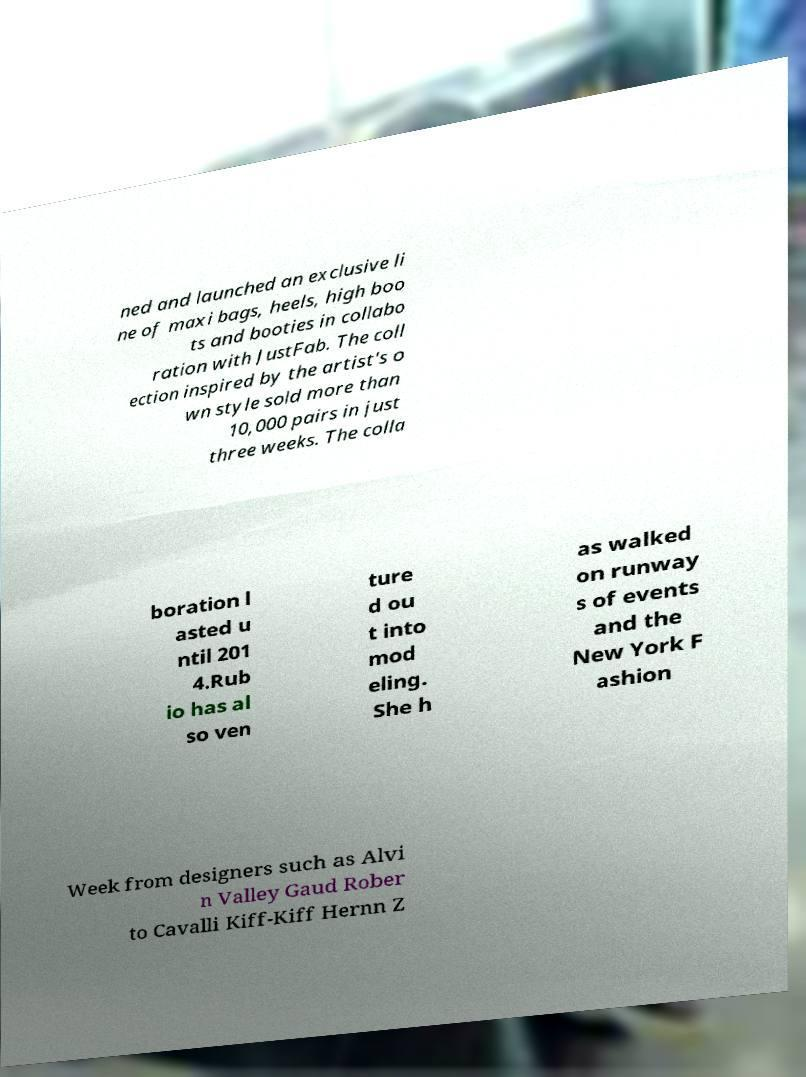I need the written content from this picture converted into text. Can you do that? ned and launched an exclusive li ne of maxi bags, heels, high boo ts and booties in collabo ration with JustFab. The coll ection inspired by the artist's o wn style sold more than 10,000 pairs in just three weeks. The colla boration l asted u ntil 201 4.Rub io has al so ven ture d ou t into mod eling. She h as walked on runway s of events and the New York F ashion Week from designers such as Alvi n Valley Gaud Rober to Cavalli Kiff-Kiff Hernn Z 